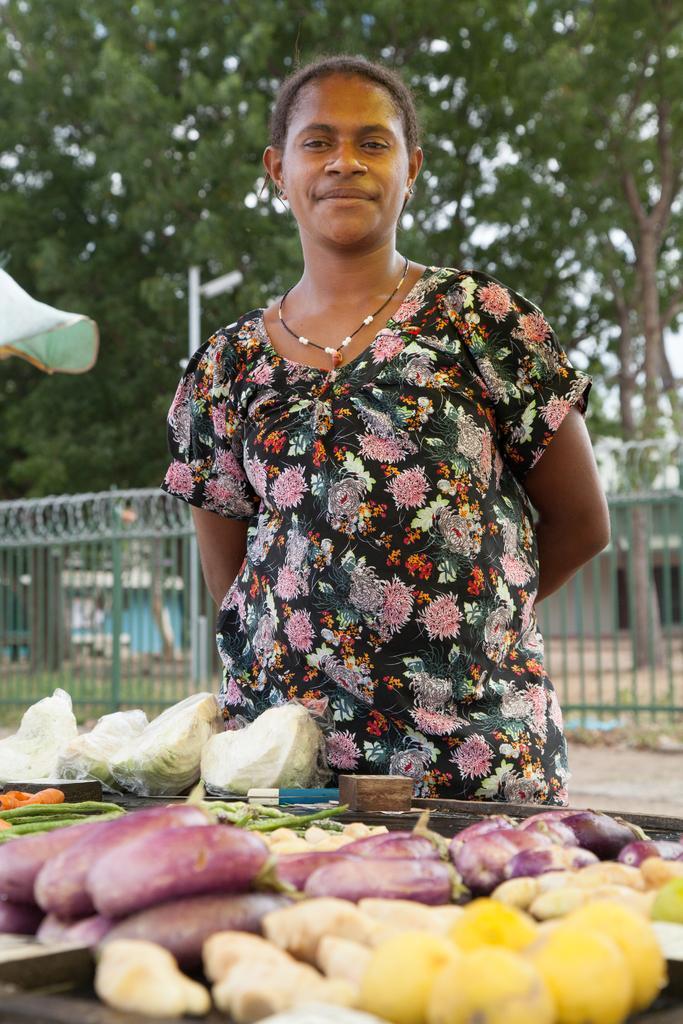Please provide a concise description of this image. In this image there is a lady standing with a smile on her face, in front of her there is a stall of vegetables, behind her there is a railing, building, trees and a pole. 